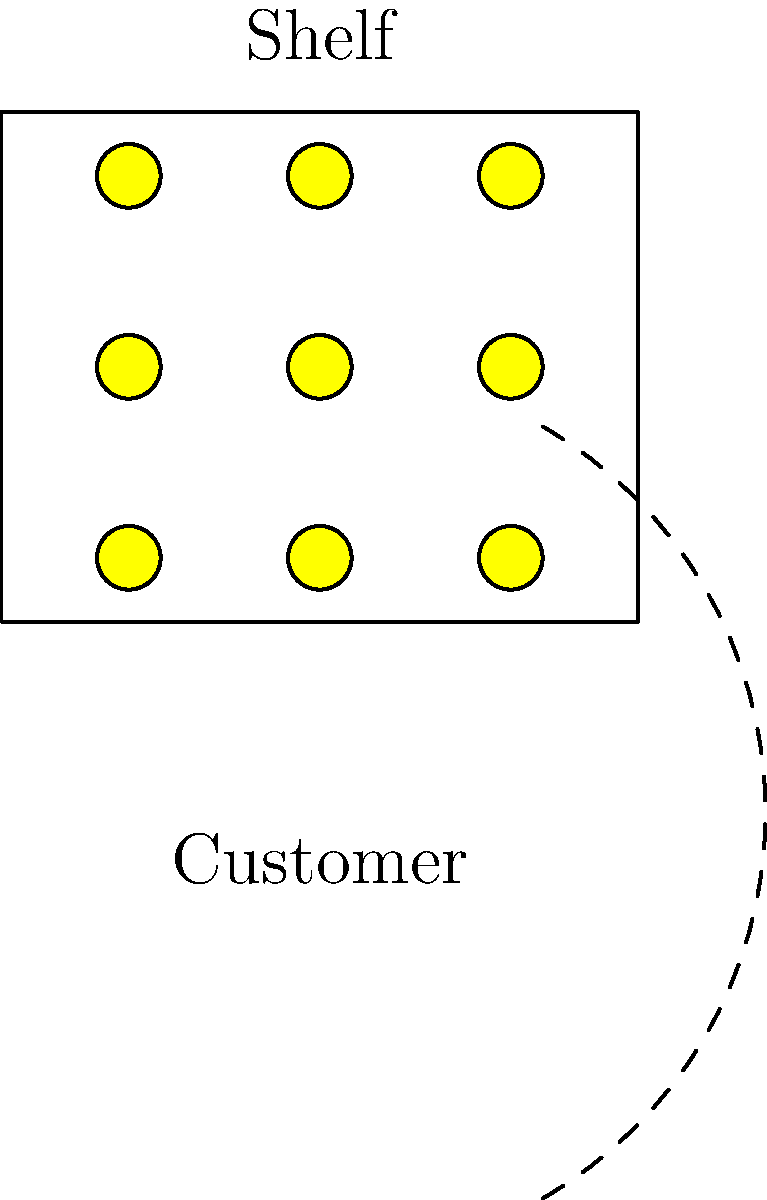Based on the diagram showing a shelf arrangement for honey products and customer reach, what is the optimal shelf height (in cm) for displaying honey jars to maximize visibility and accessibility for an average adult customer? Assume the customer's eye level is at 160 cm and their comfortable reach extends to 70 cm from their body. To determine the optimal shelf height for displaying honey products, we need to consider both visibility and accessibility for the average adult customer. Let's approach this step-by-step:

1. Given information:
   - Customer's eye level: 160 cm
   - Comfortable reach radius: 70 cm

2. Visibility consideration:
   - Products should be placed at or slightly below eye level for best visibility.
   - Ideal height range: 140-160 cm (slightly below to at eye level)

3. Accessibility consideration:
   - The bottom of the reach arc is the lowest point a customer can comfortably access.
   - To find this point, we need to calculate: $160 \text{ cm} - \sqrt{70^2 - 50^2} \approx 110 \text{ cm}$
     (assuming the customer stands about 50 cm from the shelf)

4. Optimal range:
   - The optimal shelf height should be between 110 cm and 160 cm to ensure both visibility and accessibility.

5. Determining the best height:
   - The middle of this range would be: $(110 \text{ cm} + 160 \text{ cm}) \div 2 = 135 \text{ cm}$
   - Rounding to the nearest 5 cm for practical purposes: 135 cm

Therefore, the optimal shelf height for displaying honey jars to maximize visibility and accessibility is 135 cm.
Answer: 135 cm 